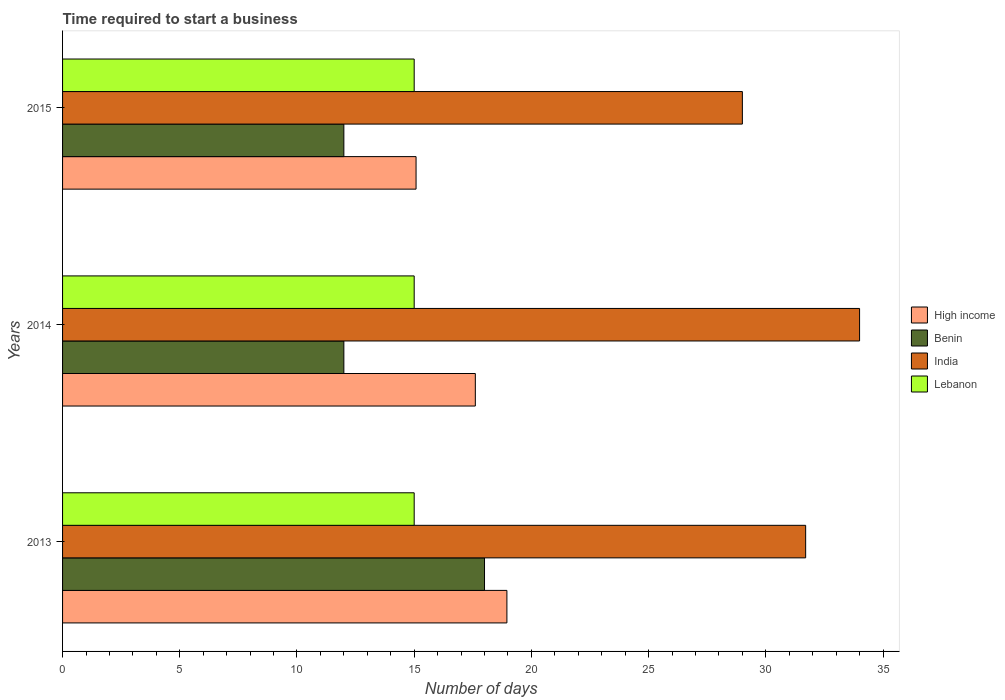How many different coloured bars are there?
Provide a short and direct response. 4. How many groups of bars are there?
Provide a succinct answer. 3. Are the number of bars per tick equal to the number of legend labels?
Provide a short and direct response. Yes. Are the number of bars on each tick of the Y-axis equal?
Keep it short and to the point. Yes. In how many cases, is the number of bars for a given year not equal to the number of legend labels?
Your response must be concise. 0. What is the number of days required to start a business in Lebanon in 2013?
Ensure brevity in your answer.  15. Across all years, what is the minimum number of days required to start a business in Lebanon?
Make the answer very short. 15. In which year was the number of days required to start a business in India minimum?
Keep it short and to the point. 2015. What is the total number of days required to start a business in Benin in the graph?
Your response must be concise. 42. What is the difference between the number of days required to start a business in India in 2013 and that in 2015?
Give a very brief answer. 2.7. What is the difference between the number of days required to start a business in Lebanon in 2014 and the number of days required to start a business in India in 2013?
Provide a short and direct response. -16.7. What is the average number of days required to start a business in Benin per year?
Keep it short and to the point. 14. In the year 2015, what is the difference between the number of days required to start a business in Lebanon and number of days required to start a business in High income?
Ensure brevity in your answer.  -0.08. In how many years, is the number of days required to start a business in Benin greater than 19 days?
Give a very brief answer. 0. Is the number of days required to start a business in Lebanon in 2014 less than that in 2015?
Offer a terse response. No. Is the difference between the number of days required to start a business in Lebanon in 2014 and 2015 greater than the difference between the number of days required to start a business in High income in 2014 and 2015?
Your answer should be very brief. No. What is the difference between the highest and the lowest number of days required to start a business in India?
Make the answer very short. 5. Is it the case that in every year, the sum of the number of days required to start a business in Lebanon and number of days required to start a business in High income is greater than the sum of number of days required to start a business in Benin and number of days required to start a business in India?
Your response must be concise. No. What does the 3rd bar from the top in 2014 represents?
Your answer should be compact. Benin. What does the 2nd bar from the bottom in 2013 represents?
Offer a terse response. Benin. Is it the case that in every year, the sum of the number of days required to start a business in High income and number of days required to start a business in Benin is greater than the number of days required to start a business in India?
Offer a terse response. No. How many years are there in the graph?
Provide a succinct answer. 3. Does the graph contain grids?
Give a very brief answer. No. Where does the legend appear in the graph?
Give a very brief answer. Center right. How many legend labels are there?
Make the answer very short. 4. What is the title of the graph?
Provide a succinct answer. Time required to start a business. What is the label or title of the X-axis?
Ensure brevity in your answer.  Number of days. What is the label or title of the Y-axis?
Make the answer very short. Years. What is the Number of days in High income in 2013?
Provide a succinct answer. 18.95. What is the Number of days in India in 2013?
Ensure brevity in your answer.  31.7. What is the Number of days in Lebanon in 2013?
Your answer should be very brief. 15. What is the Number of days in High income in 2014?
Offer a very short reply. 17.61. What is the Number of days of Benin in 2014?
Keep it short and to the point. 12. What is the Number of days of India in 2014?
Provide a succinct answer. 34. What is the Number of days in High income in 2015?
Provide a short and direct response. 15.08. What is the Number of days of India in 2015?
Your answer should be very brief. 29. Across all years, what is the maximum Number of days of High income?
Keep it short and to the point. 18.95. Across all years, what is the maximum Number of days of Benin?
Provide a short and direct response. 18. Across all years, what is the maximum Number of days in India?
Your response must be concise. 34. Across all years, what is the minimum Number of days of High income?
Your response must be concise. 15.08. Across all years, what is the minimum Number of days of Benin?
Offer a terse response. 12. What is the total Number of days in High income in the graph?
Ensure brevity in your answer.  51.64. What is the total Number of days in India in the graph?
Offer a very short reply. 94.7. What is the difference between the Number of days of High income in 2013 and that in 2014?
Your answer should be very brief. 1.35. What is the difference between the Number of days in Benin in 2013 and that in 2014?
Keep it short and to the point. 6. What is the difference between the Number of days in High income in 2013 and that in 2015?
Your answer should be very brief. 3.88. What is the difference between the Number of days in India in 2013 and that in 2015?
Provide a short and direct response. 2.7. What is the difference between the Number of days in Lebanon in 2013 and that in 2015?
Your answer should be very brief. 0. What is the difference between the Number of days of High income in 2014 and that in 2015?
Provide a short and direct response. 2.53. What is the difference between the Number of days in High income in 2013 and the Number of days in Benin in 2014?
Provide a succinct answer. 6.96. What is the difference between the Number of days in High income in 2013 and the Number of days in India in 2014?
Offer a terse response. -15.04. What is the difference between the Number of days of High income in 2013 and the Number of days of Lebanon in 2014?
Your response must be concise. 3.96. What is the difference between the Number of days in Benin in 2013 and the Number of days in India in 2014?
Make the answer very short. -16. What is the difference between the Number of days of Benin in 2013 and the Number of days of Lebanon in 2014?
Your response must be concise. 3. What is the difference between the Number of days in India in 2013 and the Number of days in Lebanon in 2014?
Make the answer very short. 16.7. What is the difference between the Number of days of High income in 2013 and the Number of days of Benin in 2015?
Offer a terse response. 6.96. What is the difference between the Number of days in High income in 2013 and the Number of days in India in 2015?
Provide a succinct answer. -10.04. What is the difference between the Number of days of High income in 2013 and the Number of days of Lebanon in 2015?
Your answer should be very brief. 3.96. What is the difference between the Number of days in Benin in 2013 and the Number of days in Lebanon in 2015?
Your answer should be compact. 3. What is the difference between the Number of days of High income in 2014 and the Number of days of Benin in 2015?
Offer a terse response. 5.61. What is the difference between the Number of days in High income in 2014 and the Number of days in India in 2015?
Provide a succinct answer. -11.39. What is the difference between the Number of days of High income in 2014 and the Number of days of Lebanon in 2015?
Offer a terse response. 2.61. What is the average Number of days of High income per year?
Your answer should be compact. 17.21. What is the average Number of days in Benin per year?
Your response must be concise. 14. What is the average Number of days of India per year?
Provide a short and direct response. 31.57. In the year 2013, what is the difference between the Number of days in High income and Number of days in Benin?
Provide a succinct answer. 0.95. In the year 2013, what is the difference between the Number of days of High income and Number of days of India?
Keep it short and to the point. -12.74. In the year 2013, what is the difference between the Number of days of High income and Number of days of Lebanon?
Give a very brief answer. 3.96. In the year 2013, what is the difference between the Number of days in Benin and Number of days in India?
Offer a terse response. -13.7. In the year 2013, what is the difference between the Number of days of Benin and Number of days of Lebanon?
Offer a terse response. 3. In the year 2014, what is the difference between the Number of days of High income and Number of days of Benin?
Your answer should be very brief. 5.61. In the year 2014, what is the difference between the Number of days in High income and Number of days in India?
Make the answer very short. -16.39. In the year 2014, what is the difference between the Number of days in High income and Number of days in Lebanon?
Offer a terse response. 2.61. In the year 2014, what is the difference between the Number of days of Benin and Number of days of Lebanon?
Provide a short and direct response. -3. In the year 2015, what is the difference between the Number of days in High income and Number of days in Benin?
Your response must be concise. 3.08. In the year 2015, what is the difference between the Number of days of High income and Number of days of India?
Offer a very short reply. -13.92. In the year 2015, what is the difference between the Number of days of Benin and Number of days of India?
Give a very brief answer. -17. In the year 2015, what is the difference between the Number of days of Benin and Number of days of Lebanon?
Make the answer very short. -3. What is the ratio of the Number of days in High income in 2013 to that in 2014?
Provide a short and direct response. 1.08. What is the ratio of the Number of days in India in 2013 to that in 2014?
Make the answer very short. 0.93. What is the ratio of the Number of days in High income in 2013 to that in 2015?
Make the answer very short. 1.26. What is the ratio of the Number of days of Benin in 2013 to that in 2015?
Offer a terse response. 1.5. What is the ratio of the Number of days of India in 2013 to that in 2015?
Make the answer very short. 1.09. What is the ratio of the Number of days in High income in 2014 to that in 2015?
Your answer should be very brief. 1.17. What is the ratio of the Number of days of India in 2014 to that in 2015?
Your answer should be compact. 1.17. What is the ratio of the Number of days in Lebanon in 2014 to that in 2015?
Your answer should be compact. 1. What is the difference between the highest and the second highest Number of days of High income?
Give a very brief answer. 1.35. What is the difference between the highest and the second highest Number of days in India?
Ensure brevity in your answer.  2.3. What is the difference between the highest and the lowest Number of days of High income?
Make the answer very short. 3.88. 